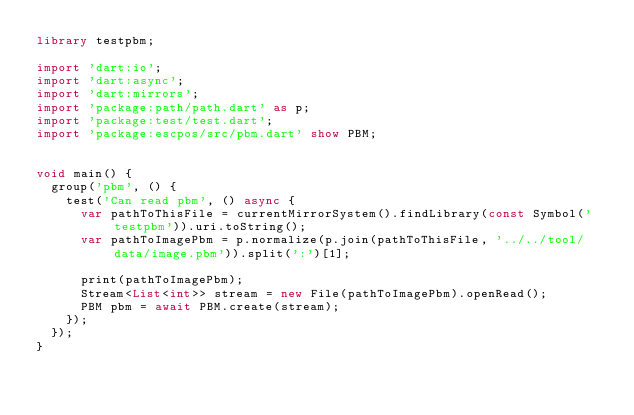<code> <loc_0><loc_0><loc_500><loc_500><_Dart_>library testpbm;

import 'dart:io';
import 'dart:async';
import 'dart:mirrors';
import 'package:path/path.dart' as p;
import 'package:test/test.dart';
import 'package:escpos/src/pbm.dart' show PBM;


void main() {
  group('pbm', () {
    test('Can read pbm', () async {
      var pathToThisFile = currentMirrorSystem().findLibrary(const Symbol('testpbm')).uri.toString();
      var pathToImagePbm = p.normalize(p.join(pathToThisFile, '../../tool/data/image.pbm')).split(':')[1];

      print(pathToImagePbm);
      Stream<List<int>> stream = new File(pathToImagePbm).openRead();
      PBM pbm = await PBM.create(stream);
    });
  });
}</code> 